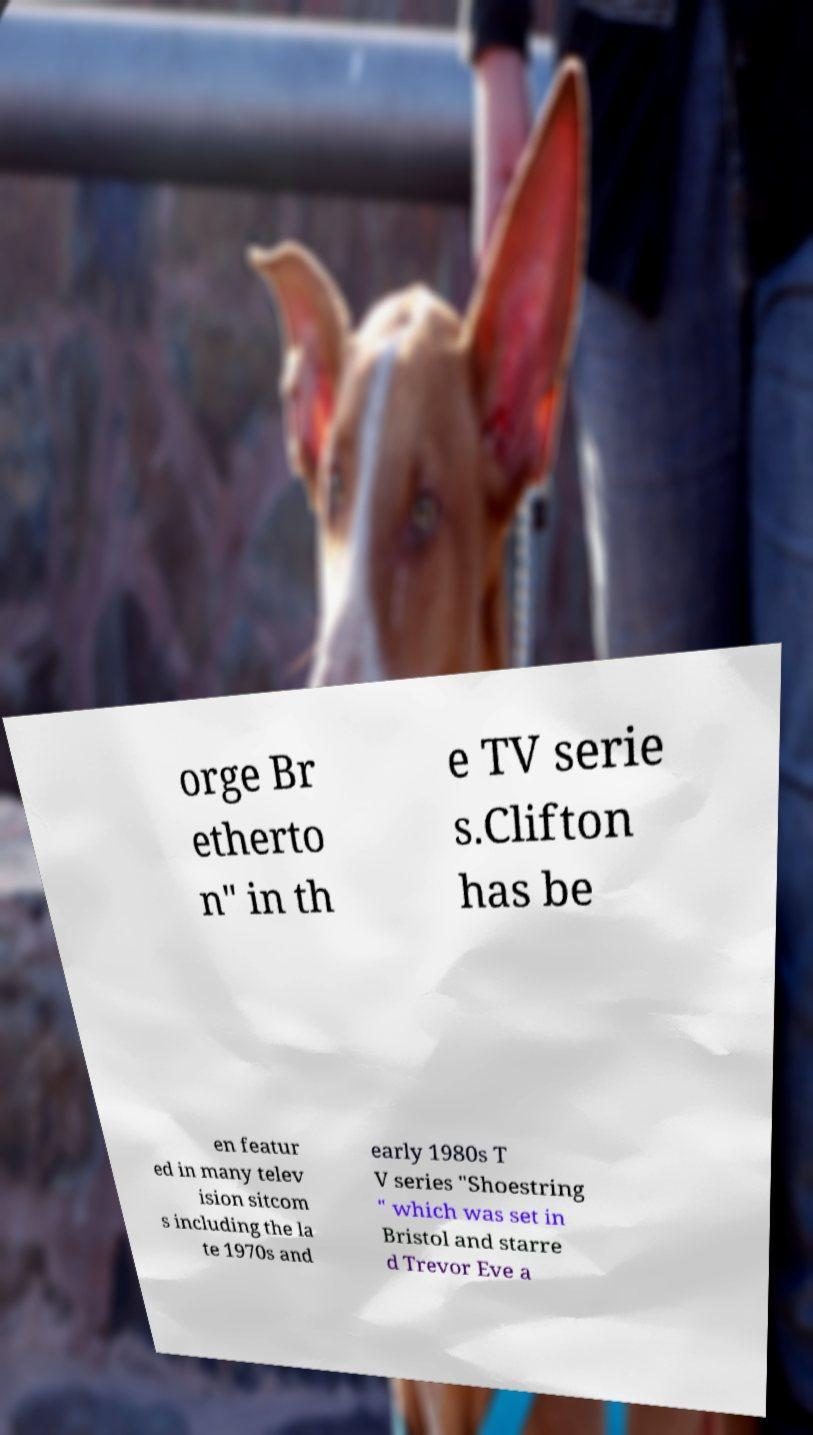What messages or text are displayed in this image? I need them in a readable, typed format. orge Br etherto n" in th e TV serie s.Clifton has be en featur ed in many telev ision sitcom s including the la te 1970s and early 1980s T V series "Shoestring " which was set in Bristol and starre d Trevor Eve a 